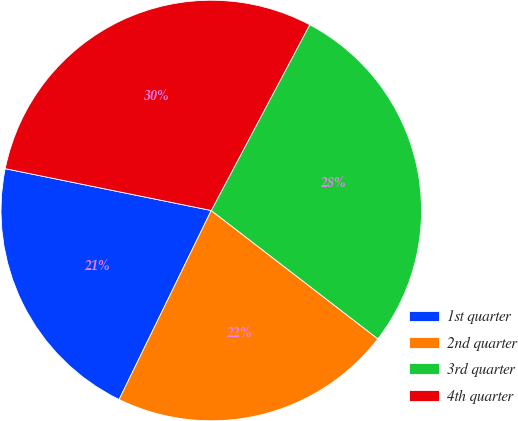<chart> <loc_0><loc_0><loc_500><loc_500><pie_chart><fcel>1st quarter<fcel>2nd quarter<fcel>3rd quarter<fcel>4th quarter<nl><fcel>20.97%<fcel>21.77%<fcel>27.69%<fcel>29.57%<nl></chart> 